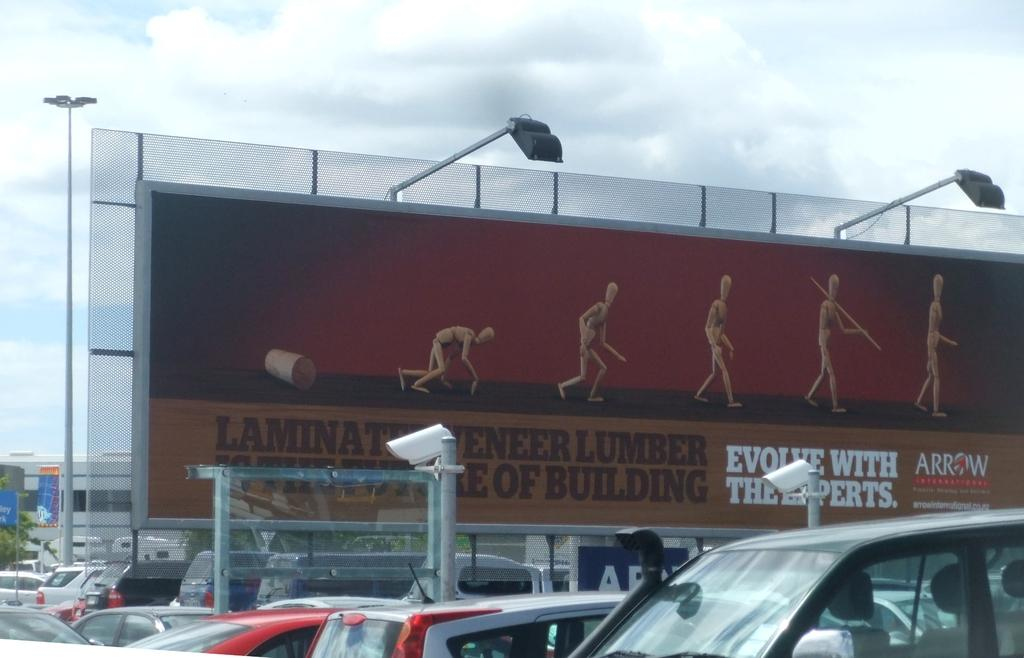<image>
Summarize the visual content of the image. Banner with lumber for building and cars parked in a parking lot 